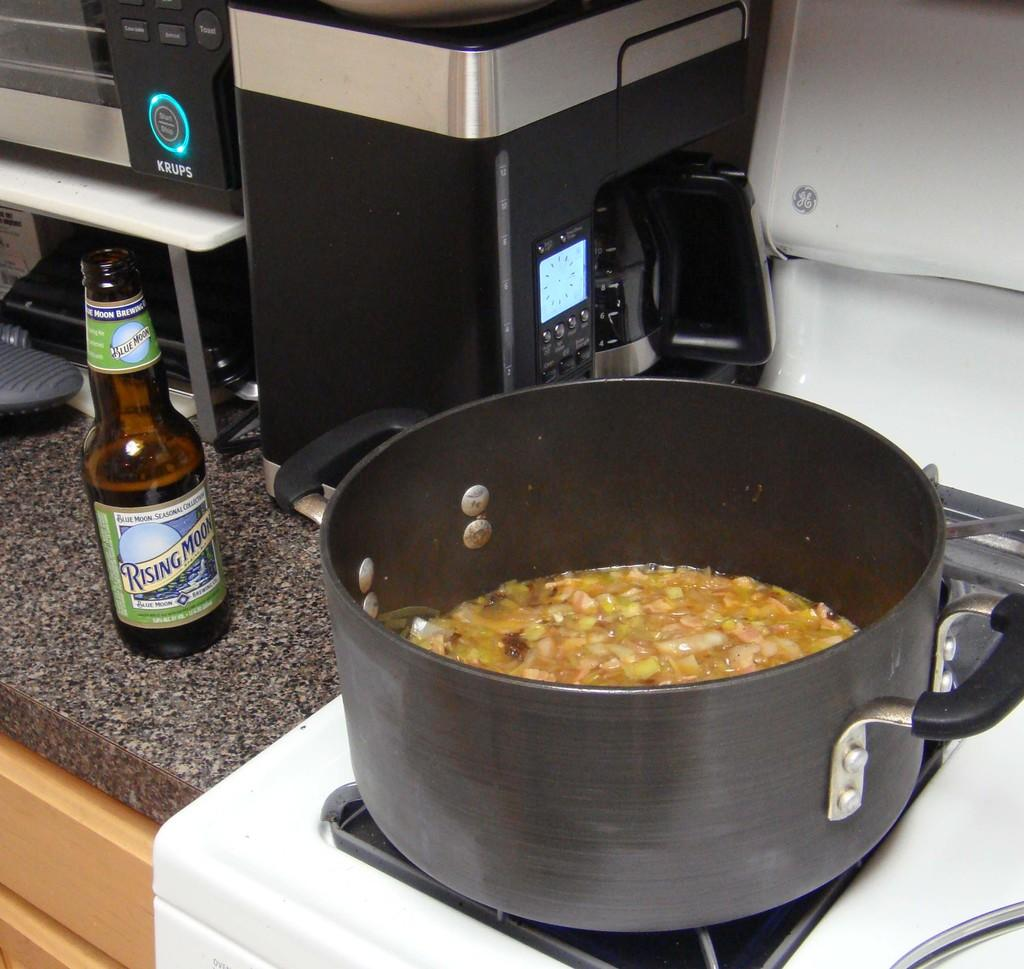<image>
Provide a brief description of the given image. A pan of broth sits on a hob next to a condiment bottle called rising moon. 